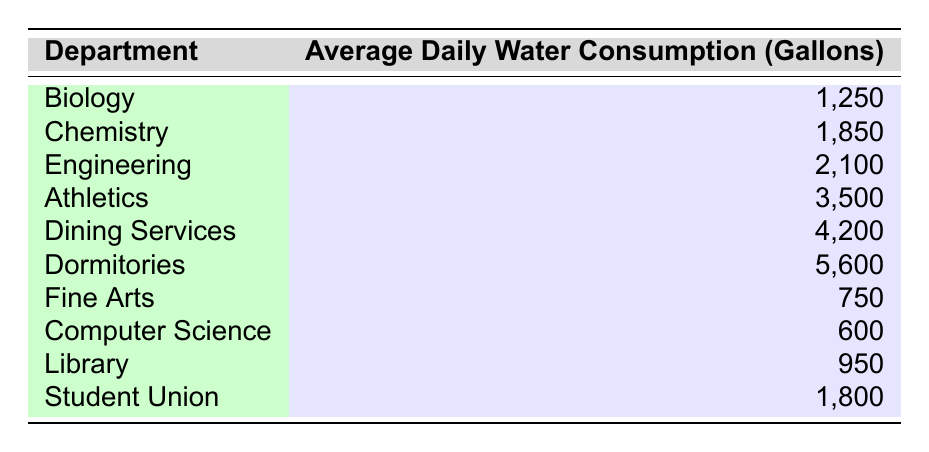What is the average daily water consumption for the Dining Services department? The values in the table indicate that the average daily water consumption for Dining Services is 4,200 gallons. Thus, the answer can be directly found by locating the corresponding row in the table.
Answer: 4,200 Which department consumes the most water daily? By inspecting the table, it is clear that the department with the highest average daily water consumption is Dormitories at 5,600 gallons. This can be identified by comparing the values across all departments in the second column.
Answer: Dormitories How many gallons more water does Athletics consume compared to Fine Arts? The average daily water consumption for Athletics is 3,500 gallons and for Fine Arts is 750 gallons. To find the difference, we subtract: 3,500 - 750 = 2,750 gallons. This step involves looking up the values for both departments and performing a simple subtraction.
Answer: 2,750 Is the average daily water consumption for Computer Science more than 1,000 gallons? The table shows that Computer Science has an average daily water consumption of 600 gallons. Since 600 is less than 1,000, the answer to the question is no. This requires checking the specific value against the threshold of 1,000.
Answer: No What is the sum of water consumption for the Biology and Chemistry departments? The average daily water consumption for Biology is 1,250 gallons, while for Chemistry it is 1,850 gallons. To find the total consumption for both departments, we add these values together: 1,250 + 1,850 = 3,100 gallons. This requires locating both values in the table and summing them up.
Answer: 3,100 Which department has a water consumption rate closest to the library's 950 gallons? Library consumes 950 gallons, and among other departments, Fine Arts consumes 750 gallons, and Computer Science consumes 600 gallons. Here, Fine Arts, with 750 gallons, is the closest to 950 gallons as it is only 200 gallons lower. This involves comparing Library's value to those of other departments.
Answer: Fine Arts What is the total average daily water consumption for all departments listed? To calculate the total water consumption, I sum all the values: 1,250 + 1,850 + 2,100 + 3,500 + 4,200 + 5,600 + 750 + 600 + 950 + 1,800 = 22,600 gallons. This involves a multi-step addition of all department consumption rates.
Answer: 22,600 Does the average daily water consumption of the Student Union exceed the average of the Biology department? The Student Union has an average daily water consumption of 1,800 gallons, whereas Biology consumes 1,250 gallons. Since 1,800 is greater than 1,250, the answer is yes. This comparison requires finding both values in the table and comparing them.
Answer: Yes 